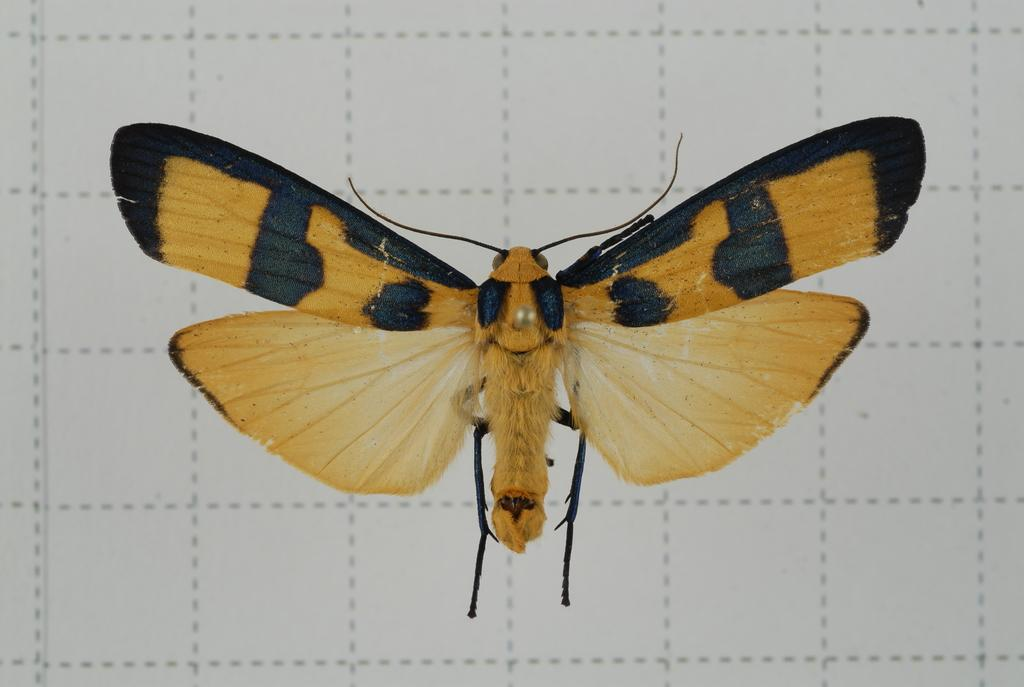What type of creature can be seen in the image? There is an insect in the image. Can you describe the object in the background of the image? The object in the background has lines on it. What type of son can be seen in the image? There is no son present in the image; it features an insect and an object with lines. What type of crate is visible in the image? There is no crate present in the image. 